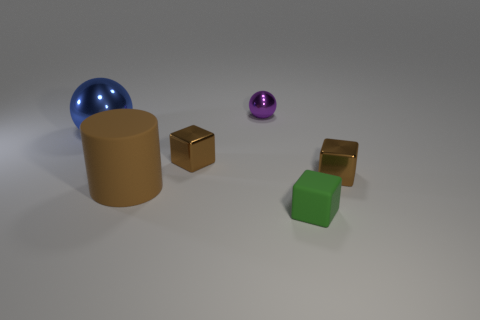What number of other things are the same color as the tiny shiny sphere?
Your answer should be compact. 0. The matte object that is behind the small green matte thing has what shape?
Offer a terse response. Cylinder. How many things are either large brown cylinders or purple metallic objects?
Offer a very short reply. 2. There is a green matte object; is it the same size as the metal object that is right of the purple thing?
Your answer should be very brief. Yes. What number of other objects are there of the same material as the green thing?
Ensure brevity in your answer.  1. What number of objects are spheres that are right of the blue thing or rubber objects on the left side of the purple shiny sphere?
Offer a very short reply. 2. There is another object that is the same shape as the tiny purple object; what material is it?
Your answer should be compact. Metal. Is there a large cylinder?
Offer a terse response. Yes. What is the size of the metallic thing that is both on the left side of the purple shiny object and to the right of the blue metallic object?
Offer a terse response. Small. What shape is the blue shiny object?
Ensure brevity in your answer.  Sphere. 